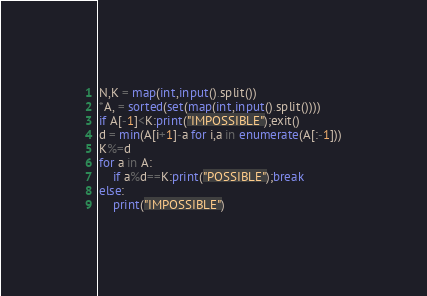Convert code to text. <code><loc_0><loc_0><loc_500><loc_500><_Python_>N,K = map(int,input().split())
*A, = sorted(set(map(int,input().split())))
if A[-1]<K:print("IMPOSSIBLE");exit()
d = min(A[i+1]-a for i,a in enumerate(A[:-1]))
K%=d
for a in A:
    if a%d==K:print("POSSIBLE");break
else:
    print("IMPOSSIBLE")</code> 